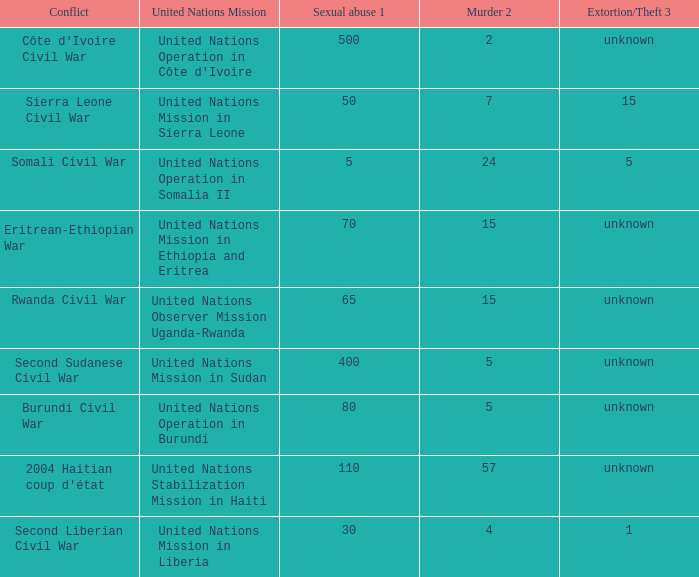Parse the table in full. {'header': ['Conflict', 'United Nations Mission', 'Sexual abuse 1', 'Murder 2', 'Extortion/Theft 3'], 'rows': [["Côte d'Ivoire Civil War", "United Nations Operation in Côte d'Ivoire", '500', '2', 'unknown'], ['Sierra Leone Civil War', 'United Nations Mission in Sierra Leone', '50', '7', '15'], ['Somali Civil War', 'United Nations Operation in Somalia II', '5', '24', '5'], ['Eritrean-Ethiopian War', 'United Nations Mission in Ethiopia and Eritrea', '70', '15', 'unknown'], ['Rwanda Civil War', 'United Nations Observer Mission Uganda-Rwanda', '65', '15', 'unknown'], ['Second Sudanese Civil War', 'United Nations Mission in Sudan', '400', '5', 'unknown'], ['Burundi Civil War', 'United Nations Operation in Burundi', '80', '5', 'unknown'], ["2004 Haitian coup d'état", 'United Nations Stabilization Mission in Haiti', '110', '57', 'unknown'], ['Second Liberian Civil War', 'United Nations Mission in Liberia', '30', '4', '1']]} What is the sexual abuse rate where the conflict is the Burundi Civil War? 80.0. 